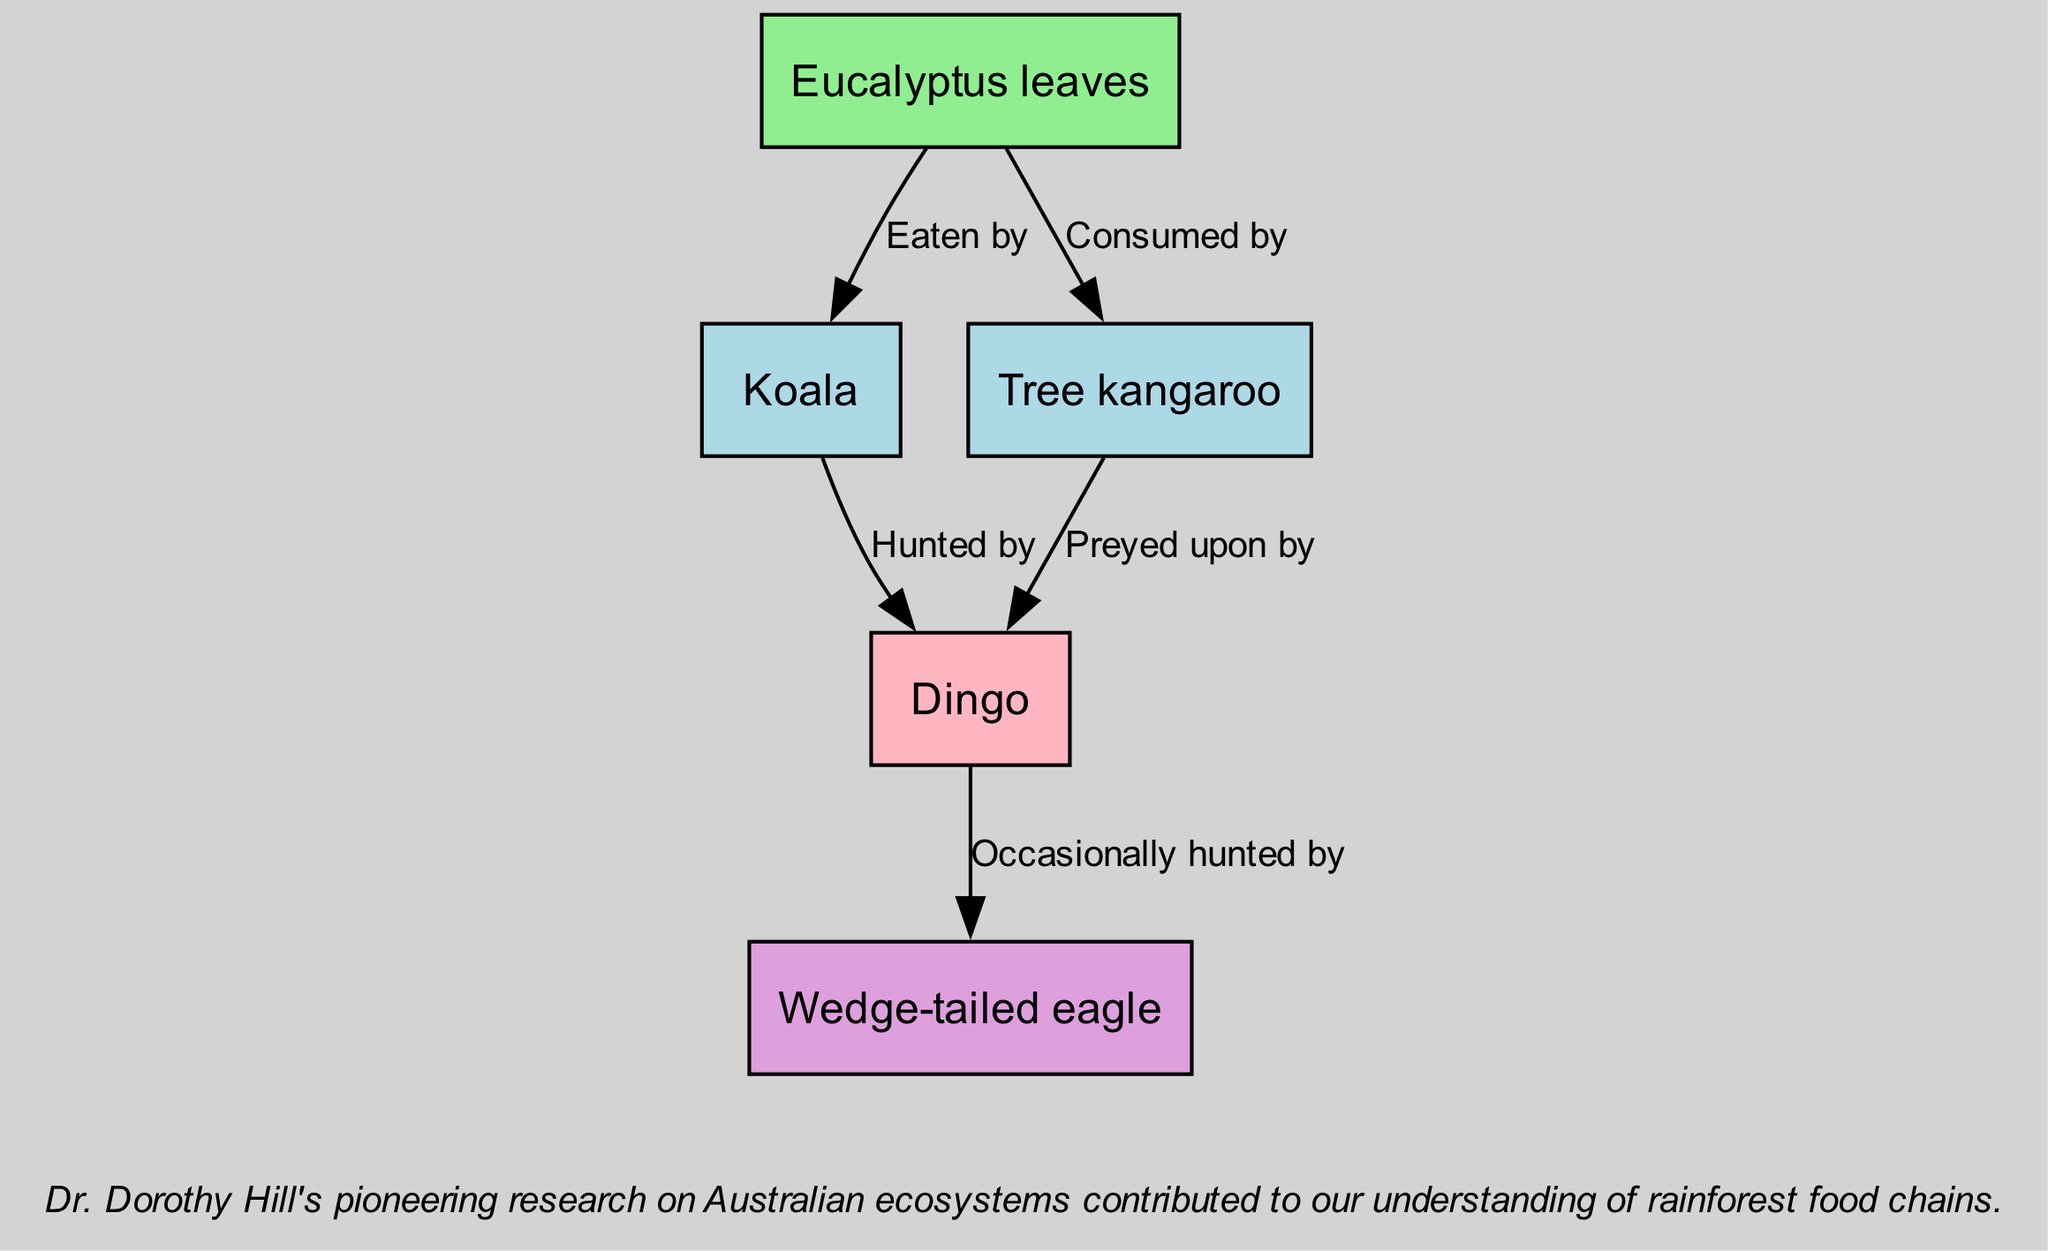What is the primary producer in the food chain? The diagram indicates that Eucalyptus leaves are classified as the primary producer, as they produce energy through photosynthesis.
Answer: Eucalyptus leaves How many primary consumers are there? By examining the diagram, I can see there are two primary consumers: Koala and Tree kangaroo.
Answer: 2 Who hunts the Koala? According to the diagram, the Dingo is shown as the organism that hunts the Koala, illustrating the predator-prey relationship.
Answer: Dingo What is the role of the Tree kangaroo? The Tree kangaroo is classified as a primary consumer in the diagram, as it feeds directly on the primary producer, the Eucalyptus leaves.
Answer: Primary Consumer Which consumer is occasionally hunted by the Wedge-tailed eagle? The diagram illustrates that the Dingo is occasionally hunted by the Wedge-tailed eagle, indicating a tertiary consumer's relationship with a secondary consumer.
Answer: Dingo How many edges connect the primary consumers to their predators? There are four edges in the diagram that connect the two primary consumers (Koala and Tree kangaroo) to their common predator (Dingo).
Answer: 4 What type of consumer is the Wedge-tailed eagle? The Wedge-tailed eagle is categorized as a tertiary consumer in the diagram, indicating its position at the top of the food chain.
Answer: Tertiary Consumer Name one animal that consumes Eucalyptus leaves. The diagram shows that both the Koala and the Tree kangaroo consume Eucalyptus leaves, among other aspects of the food chain.
Answer: Koala What color represents secondary consumers in the diagram? The diagram indicates that secondary consumers are represented in pink (#FFB6C1), highlighting their distinct role in the food chain.
Answer: Pink 